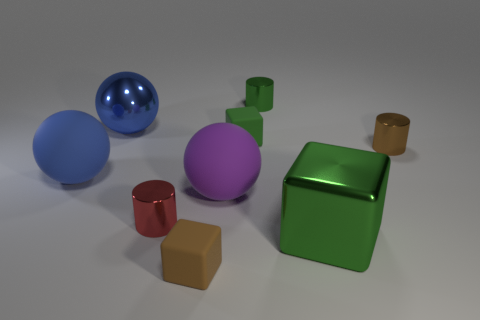There is a matte cube that is behind the rubber object in front of the tiny shiny cylinder in front of the big blue rubber thing; how big is it?
Offer a very short reply. Small. What number of other objects are the same material as the tiny brown cylinder?
Your answer should be compact. 4. What color is the small metal cylinder behind the big blue shiny thing?
Provide a succinct answer. Green. There is a green thing in front of the shiny cylinder that is in front of the sphere that is to the right of the small red metal object; what is it made of?
Keep it short and to the point. Metal. Is there a big blue metallic object that has the same shape as the large purple rubber thing?
Offer a terse response. Yes. There is a purple rubber thing that is the same size as the metal cube; what is its shape?
Give a very brief answer. Sphere. What number of things are right of the red metal cylinder and behind the red metal cylinder?
Your answer should be very brief. 4. Is the number of purple balls that are behind the small red metal cylinder less than the number of large objects?
Give a very brief answer. Yes. Is there a matte cube that has the same size as the brown metal cylinder?
Ensure brevity in your answer.  Yes. There is a large ball that is made of the same material as the large cube; what is its color?
Your answer should be compact. Blue. 